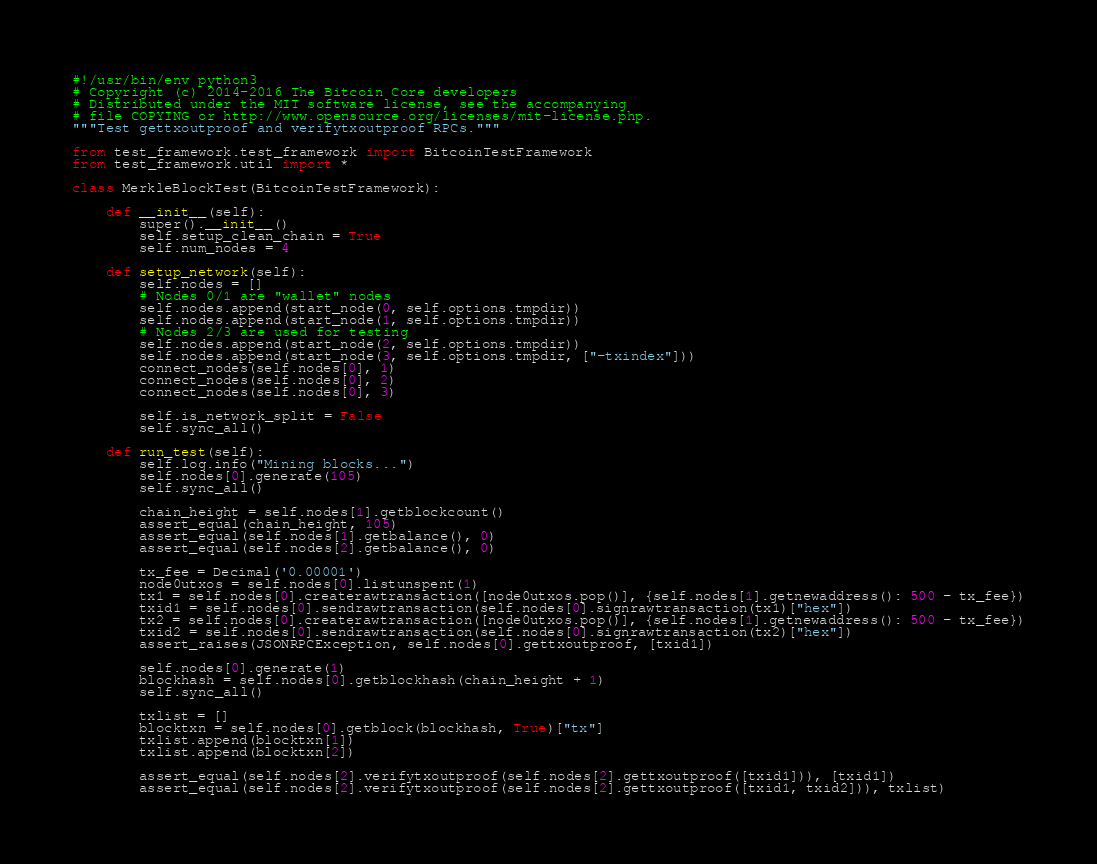Convert code to text. <code><loc_0><loc_0><loc_500><loc_500><_Python_>#!/usr/bin/env python3
# Copyright (c) 2014-2016 The Bitcoin Core developers
# Distributed under the MIT software license, see the accompanying
# file COPYING or http://www.opensource.org/licenses/mit-license.php.
"""Test gettxoutproof and verifytxoutproof RPCs."""

from test_framework.test_framework import BitcoinTestFramework
from test_framework.util import *

class MerkleBlockTest(BitcoinTestFramework):

    def __init__(self):
        super().__init__()
        self.setup_clean_chain = True
        self.num_nodes = 4

    def setup_network(self):
        self.nodes = []
        # Nodes 0/1 are "wallet" nodes
        self.nodes.append(start_node(0, self.options.tmpdir))
        self.nodes.append(start_node(1, self.options.tmpdir))
        # Nodes 2/3 are used for testing
        self.nodes.append(start_node(2, self.options.tmpdir))
        self.nodes.append(start_node(3, self.options.tmpdir, ["-txindex"]))
        connect_nodes(self.nodes[0], 1)
        connect_nodes(self.nodes[0], 2)
        connect_nodes(self.nodes[0], 3)

        self.is_network_split = False
        self.sync_all()

    def run_test(self):
        self.log.info("Mining blocks...")
        self.nodes[0].generate(105)
        self.sync_all()

        chain_height = self.nodes[1].getblockcount()
        assert_equal(chain_height, 105)
        assert_equal(self.nodes[1].getbalance(), 0)
        assert_equal(self.nodes[2].getbalance(), 0)

        tx_fee = Decimal('0.00001')
        node0utxos = self.nodes[0].listunspent(1)
        tx1 = self.nodes[0].createrawtransaction([node0utxos.pop()], {self.nodes[1].getnewaddress(): 500 - tx_fee})
        txid1 = self.nodes[0].sendrawtransaction(self.nodes[0].signrawtransaction(tx1)["hex"])
        tx2 = self.nodes[0].createrawtransaction([node0utxos.pop()], {self.nodes[1].getnewaddress(): 500 - tx_fee})
        txid2 = self.nodes[0].sendrawtransaction(self.nodes[0].signrawtransaction(tx2)["hex"])
        assert_raises(JSONRPCException, self.nodes[0].gettxoutproof, [txid1])

        self.nodes[0].generate(1)
        blockhash = self.nodes[0].getblockhash(chain_height + 1)
        self.sync_all()

        txlist = []
        blocktxn = self.nodes[0].getblock(blockhash, True)["tx"]
        txlist.append(blocktxn[1])
        txlist.append(blocktxn[2])

        assert_equal(self.nodes[2].verifytxoutproof(self.nodes[2].gettxoutproof([txid1])), [txid1])
        assert_equal(self.nodes[2].verifytxoutproof(self.nodes[2].gettxoutproof([txid1, txid2])), txlist)</code> 